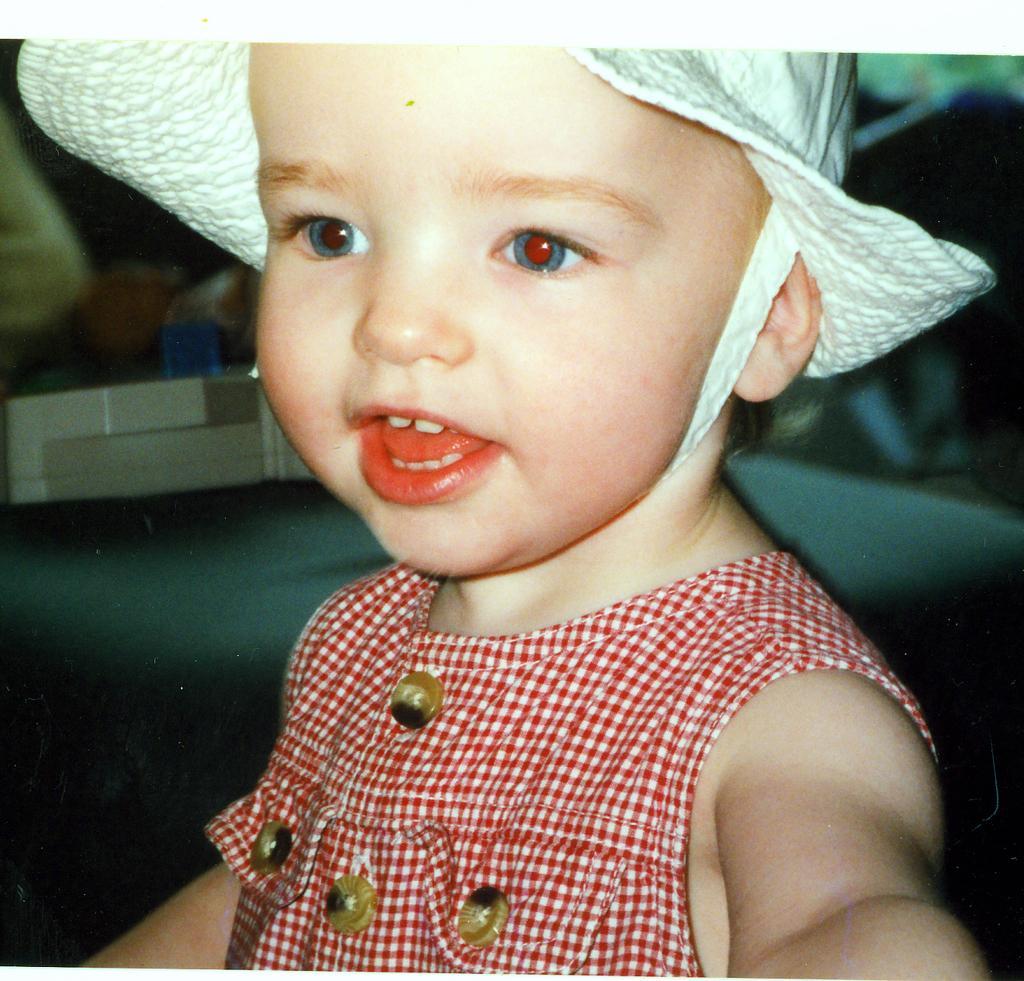Can you describe this image briefly? In this image we can see there is a kid wearing a hat on his head. 